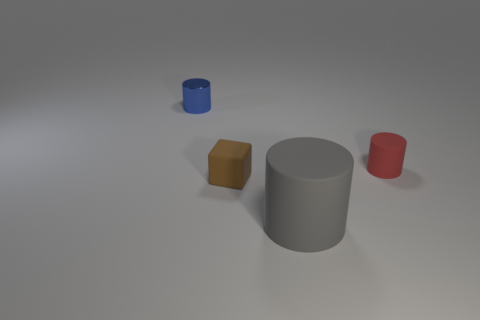Add 3 tiny brown things. How many objects exist? 7 Subtract all rubber cylinders. How many cylinders are left? 1 Subtract all red cylinders. How many cylinders are left? 2 Subtract all blocks. How many objects are left? 3 Add 2 small rubber cubes. How many small rubber cubes are left? 3 Add 1 tiny green shiny spheres. How many tiny green shiny spheres exist? 1 Subtract 0 yellow balls. How many objects are left? 4 Subtract all green cubes. Subtract all purple balls. How many cubes are left? 1 Subtract all cyan spheres. How many gray cylinders are left? 1 Subtract all cyan matte spheres. Subtract all large gray cylinders. How many objects are left? 3 